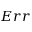Convert formula to latex. <formula><loc_0><loc_0><loc_500><loc_500>E r r</formula> 